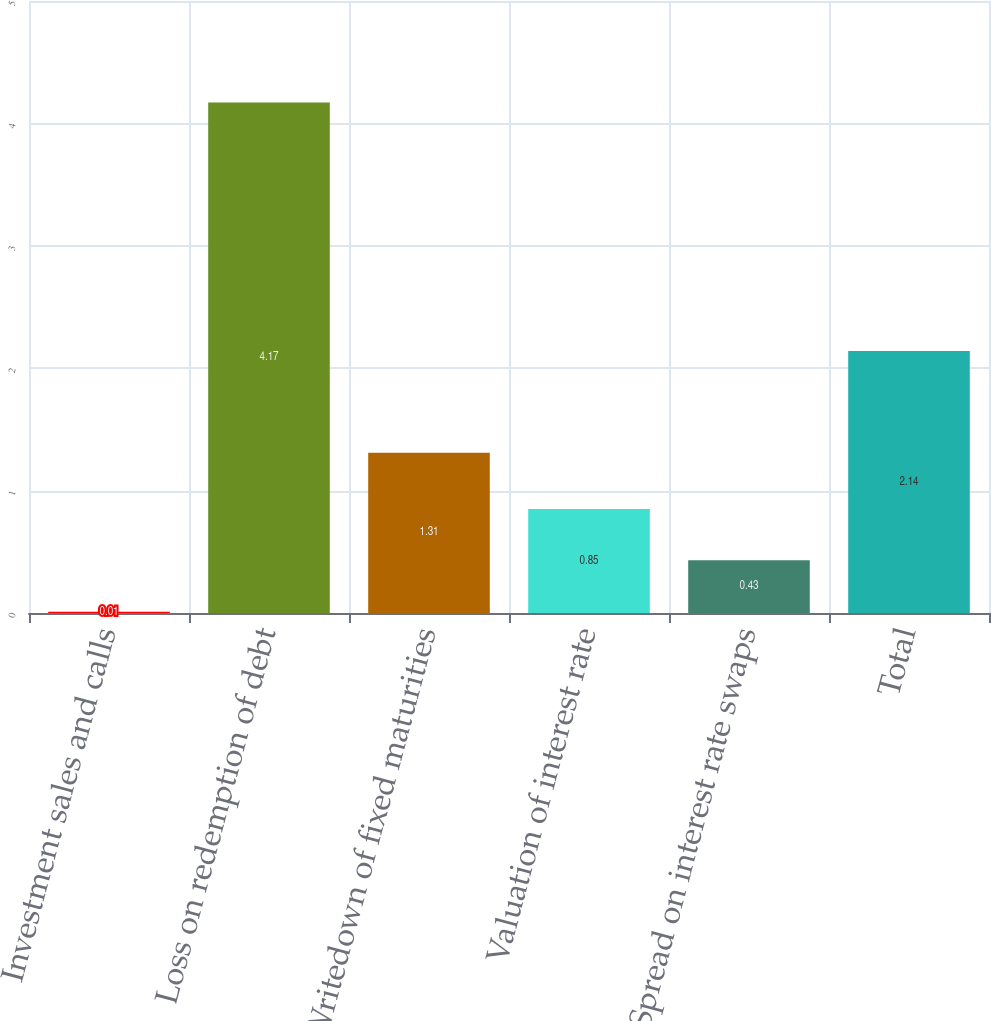Convert chart to OTSL. <chart><loc_0><loc_0><loc_500><loc_500><bar_chart><fcel>Investment sales and calls<fcel>Loss on redemption of debt<fcel>Writedown of fixed maturities<fcel>Valuation of interest rate<fcel>Spread on interest rate swaps<fcel>Total<nl><fcel>0.01<fcel>4.17<fcel>1.31<fcel>0.85<fcel>0.43<fcel>2.14<nl></chart> 